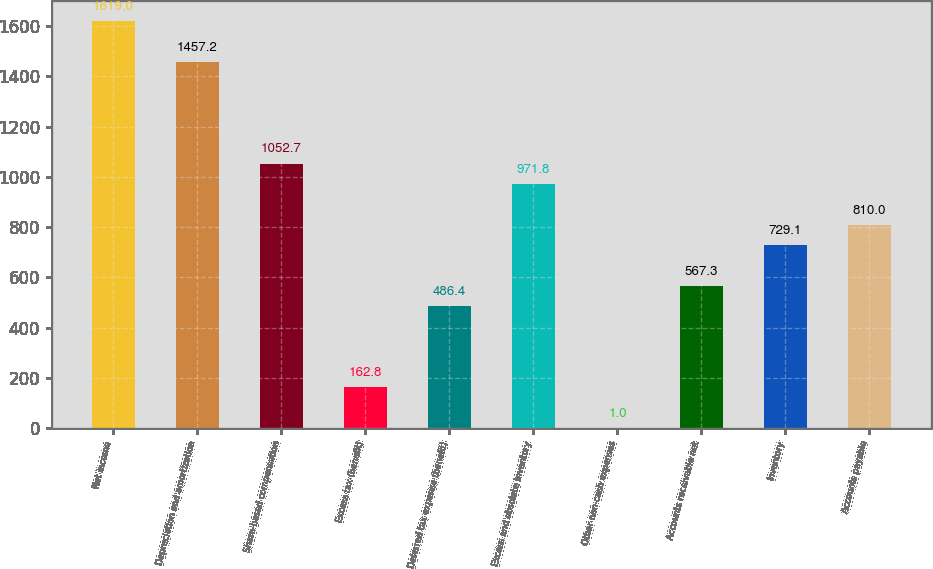Convert chart to OTSL. <chart><loc_0><loc_0><loc_500><loc_500><bar_chart><fcel>Net income<fcel>Depreciation and amortization<fcel>Share-based compensation<fcel>Excess tax (benefit)<fcel>Deferred tax expense (benefit)<fcel>Excess and obsolete inventory<fcel>Other non-cash expenses<fcel>Accounts receivable net<fcel>Inventory<fcel>Accounts payable<nl><fcel>1619<fcel>1457.2<fcel>1052.7<fcel>162.8<fcel>486.4<fcel>971.8<fcel>1<fcel>567.3<fcel>729.1<fcel>810<nl></chart> 